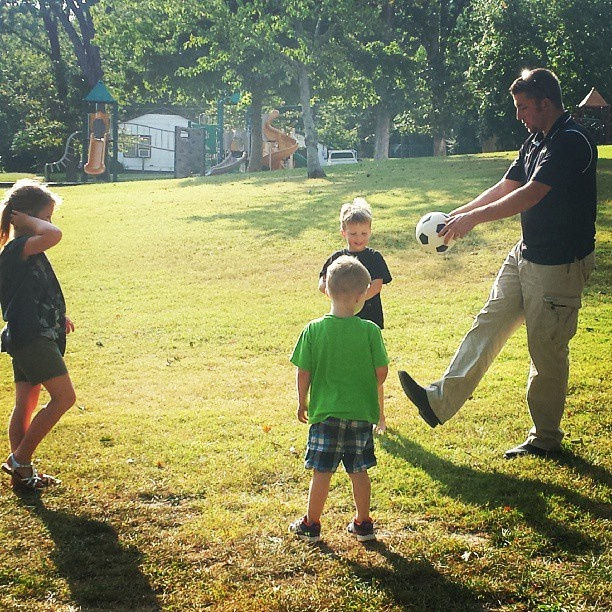Describe the objects in this image and their specific colors. I can see people in lightgray, black, gray, darkgreen, and ivory tones, people in lightgray, darkgreen, black, and gray tones, people in lightgray, black, maroon, and gray tones, people in lightgray, black, tan, gray, and ivory tones, and sports ball in lightgray, beige, and tan tones in this image. 